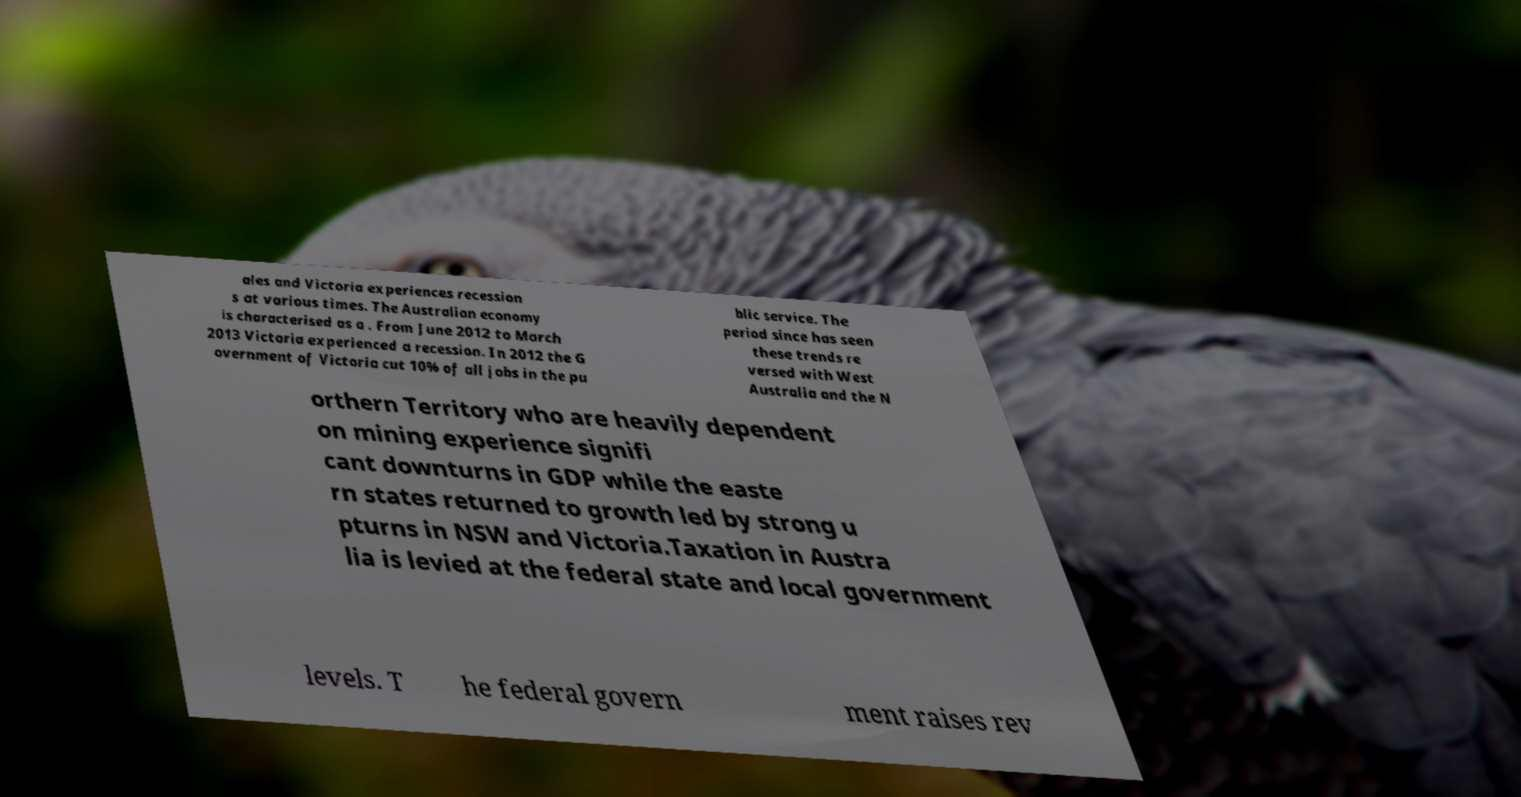Could you extract and type out the text from this image? ales and Victoria experiences recession s at various times. The Australian economy is characterised as a . From June 2012 to March 2013 Victoria experienced a recession. In 2012 the G overnment of Victoria cut 10% of all jobs in the pu blic service. The period since has seen these trends re versed with West Australia and the N orthern Territory who are heavily dependent on mining experience signifi cant downturns in GDP while the easte rn states returned to growth led by strong u pturns in NSW and Victoria.Taxation in Austra lia is levied at the federal state and local government levels. T he federal govern ment raises rev 